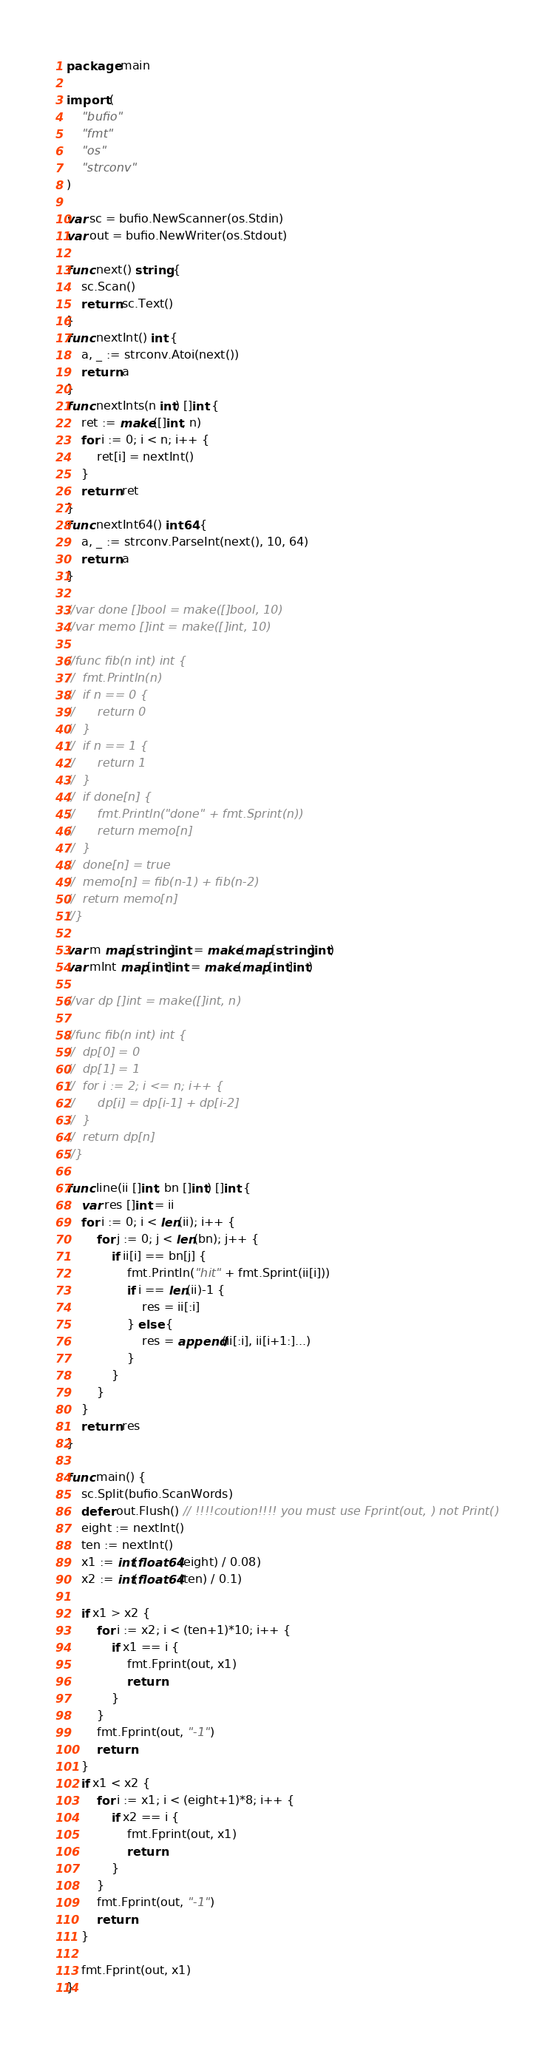<code> <loc_0><loc_0><loc_500><loc_500><_Go_>package main

import (
	"bufio"
	"fmt"
	"os"
	"strconv"
)

var sc = bufio.NewScanner(os.Stdin)
var out = bufio.NewWriter(os.Stdout)

func next() string {
	sc.Scan()
	return sc.Text()
}
func nextInt() int {
	a, _ := strconv.Atoi(next())
	return a
}
func nextInts(n int) []int {
	ret := make([]int, n)
	for i := 0; i < n; i++ {
		ret[i] = nextInt()
	}
	return ret
}
func nextInt64() int64 {
	a, _ := strconv.ParseInt(next(), 10, 64)
	return a
}

//var done []bool = make([]bool, 10)
//var memo []int = make([]int, 10)

//func fib(n int) int {
//	fmt.Println(n)
//	if n == 0 {
//		return 0
//	}
//	if n == 1 {
//		return 1
//	}
//	if done[n] {
//		fmt.Println("done" + fmt.Sprint(n))
//		return memo[n]
//	}
//	done[n] = true
//	memo[n] = fib(n-1) + fib(n-2)
//	return memo[n]
//}

var m map[string]int = make(map[string]int)
var mInt map[int]int = make(map[int]int)

//var dp []int = make([]int, n)

//func fib(n int) int {
//	dp[0] = 0
//	dp[1] = 1
//	for i := 2; i <= n; i++ {
//		dp[i] = dp[i-1] + dp[i-2]
//	}
//	return dp[n]
//}

func line(ii []int, bn []int) []int {
	var res []int = ii
	for i := 0; i < len(ii); i++ {
		for j := 0; j < len(bn); j++ {
			if ii[i] == bn[j] {
				fmt.Println("hit" + fmt.Sprint(ii[i]))
				if i == len(ii)-1 {
					res = ii[:i]
				} else {
					res = append(ii[:i], ii[i+1:]...)
				}
			}
		}
	}
	return res
}

func main() {
	sc.Split(bufio.ScanWords)
	defer out.Flush() // !!!!coution!!!! you must use Fprint(out, ) not Print()
	eight := nextInt()
	ten := nextInt()
	x1 := int(float64(eight) / 0.08)
	x2 := int(float64(ten) / 0.1)

	if x1 > x2 {
		for i := x2; i < (ten+1)*10; i++ {
			if x1 == i {
				fmt.Fprint(out, x1)
				return
			}
		}
		fmt.Fprint(out, "-1")
		return
	}
	if x1 < x2 {
		for i := x1; i < (eight+1)*8; i++ {
			if x2 == i {
				fmt.Fprint(out, x1)
				return
			}
		}
		fmt.Fprint(out, "-1")
		return
	}

	fmt.Fprint(out, x1)
}
</code> 